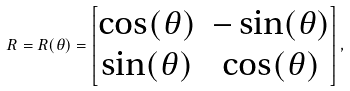<formula> <loc_0><loc_0><loc_500><loc_500>R = R ( \theta ) = \begin{bmatrix} \cos ( \theta ) & - \sin ( \theta ) \\ \sin ( \theta ) & \cos ( \theta ) \end{bmatrix} ,</formula> 